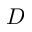Convert formula to latex. <formula><loc_0><loc_0><loc_500><loc_500>D</formula> 